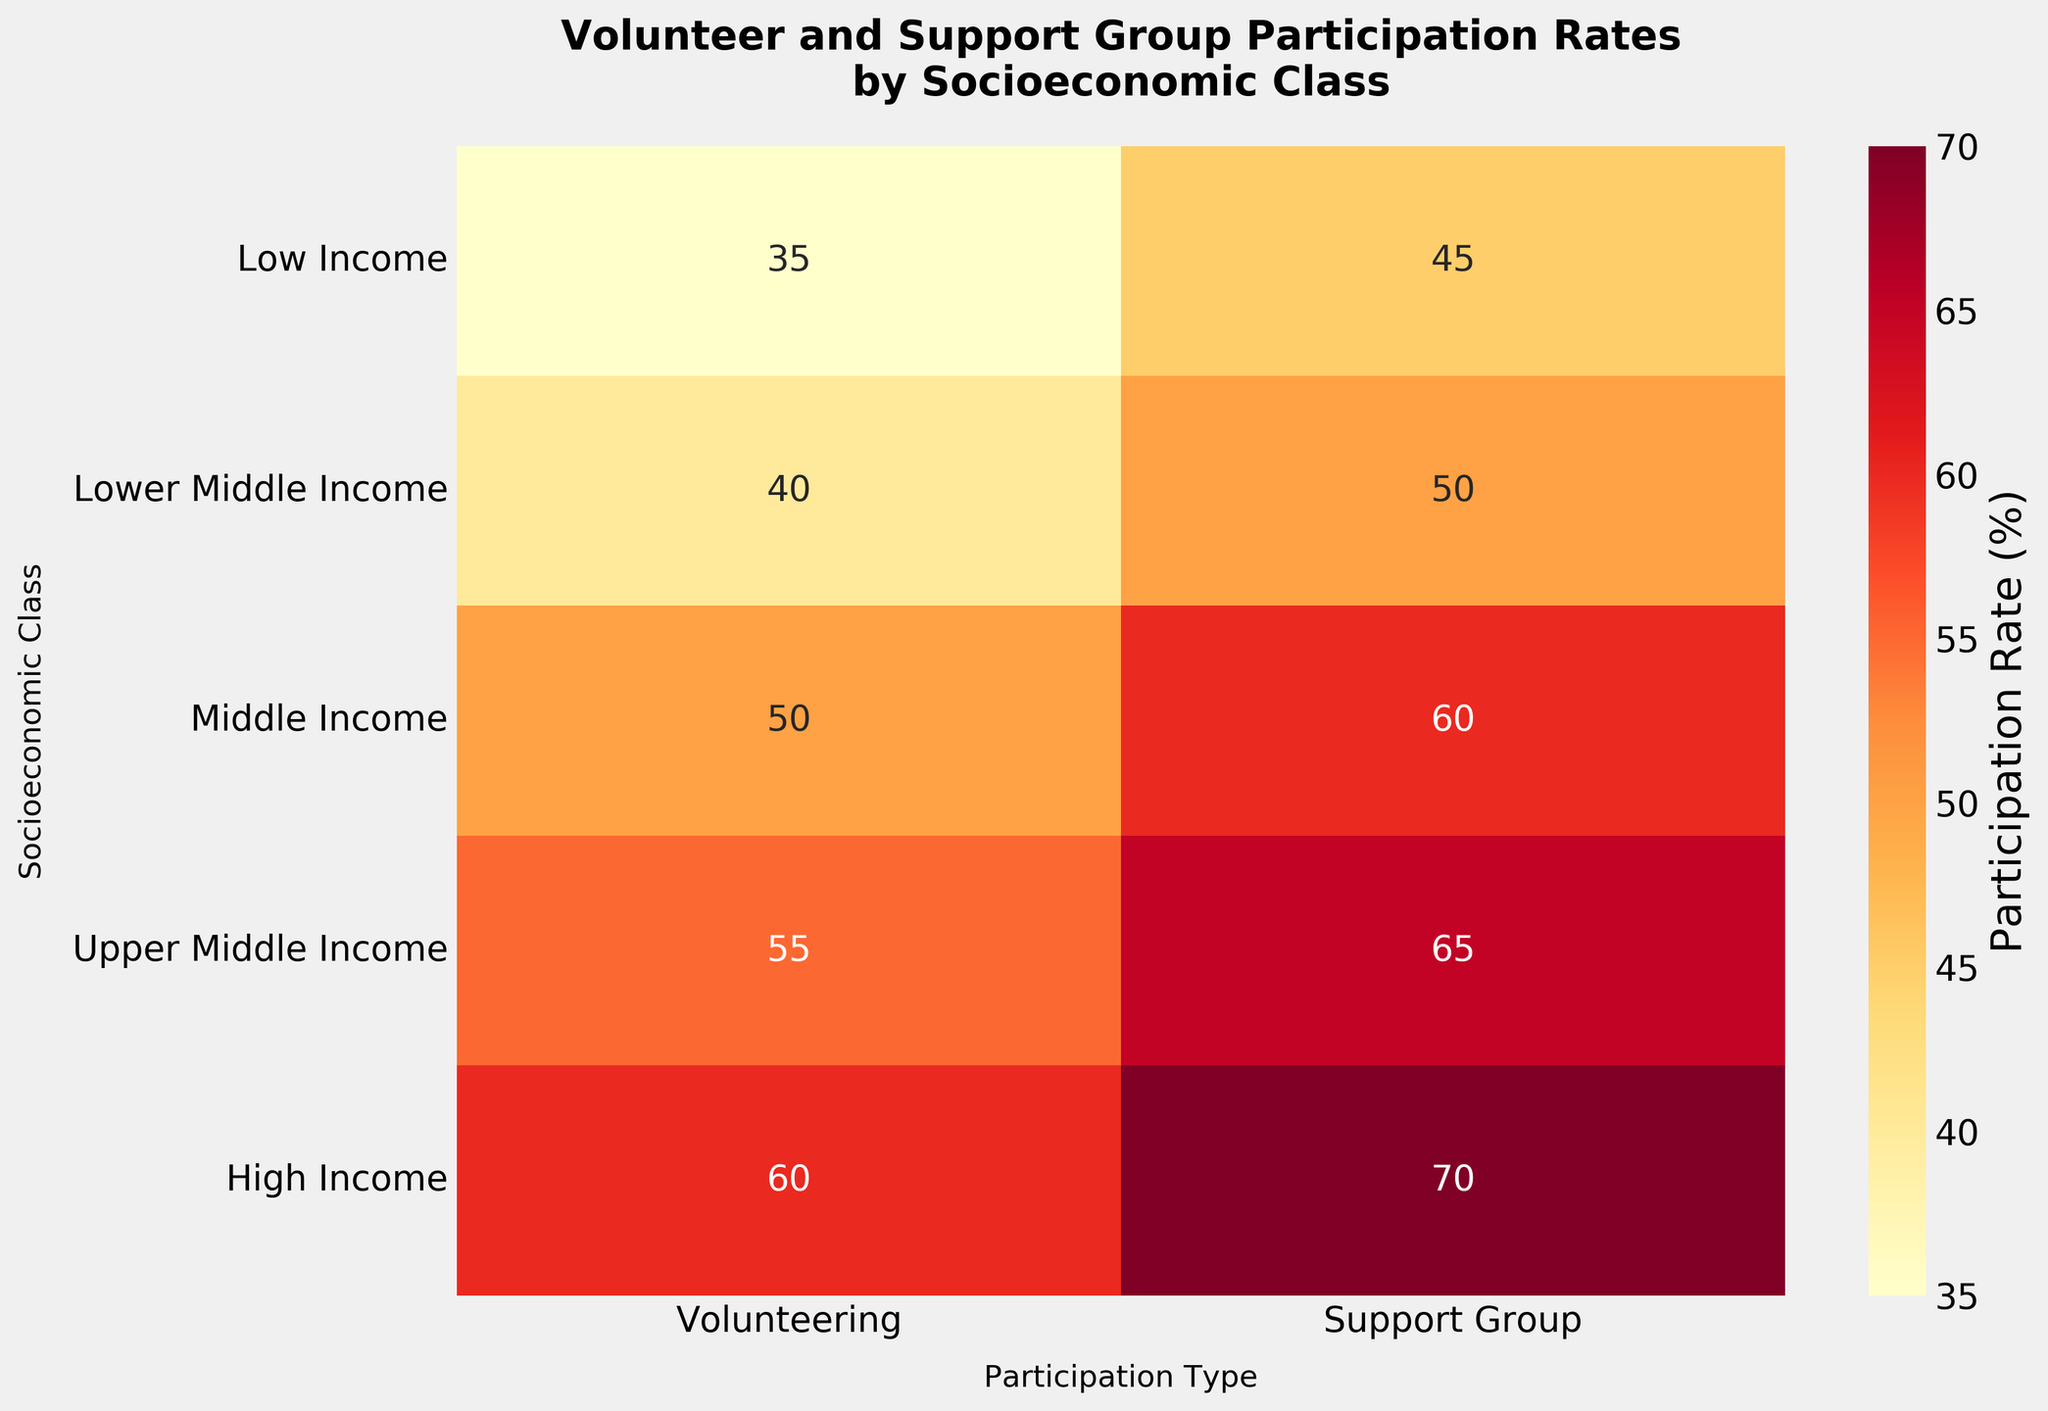What is the title of the heatmap? The title is usually displayed at the top of the heatmap. It reads "Volunteer and Support Group Participation Rates by Socioeconomic Class".
Answer: Volunteer and Support Group Participation Rates by Socioeconomic Class Which socioeconomic class has the highest volunteering rate? The heatmap shows the highest value in the "Volunteering" column, which corresponds to the "High Income" row.
Answer: High Income What is the volunteering rate for the Upper Middle Income class? The heatmap annotates values in each cell. The cell at the intersection of "Upper Middle Income" and "Volunteering" shows the number 55.
Answer: 55 How does the support group participation rate of the Low Income class compare to its volunteering rate? Compare the values in the "Low Income" row across the two columns. The "Support Group" column shows 45, which is higher than 35 in the "Volunteering" column.
Answer: Support group participation rate is higher What is the average support group participation rate across all socioeconomic classes? Sum the support group participation rates: 45, 50, 60, 65, and 70, which equals 290. Then divide by the total number of rows, which is 5: 290/5 = 58.
Answer: 58 Which socioeconomic class has the smallest difference between volunteering and support group participation rates? Calculate the differences for each class:
Low Income: 45 - 35 = 10
Lower Middle Income: 50 - 40 = 10
Middle Income: 60 - 50 = 10
Upper Middle Income: 65 - 55 = 10
High Income: 70 - 60 = 10
All differences are equal, so every class has an equal smallest difference of 10.
Answer: All classes have the smallest difference of 10 Is there a trend in participation rates as you move from Low Income to High Income? Observe the values in both columns; rates for volunteering and support group participation increase consistently from Low Income to High Income.
Answer: Yes, there is an increasing trend What is the total participation rate combining both volunteering and support group participation for the Middle Income class? Sum the Middle Income class rates for both columns: 50 (Volunteering) + 60 (Support Group) = 110.
Answer: 110 What is the general color trend observed in the heatmap as socioeconomic class increases? The color gradient shifts from lighter to darker shades which can be interpreted as lower to higher values in the scale, indicating increased participation rates.
Answer: Color darkens What is the overall range of participation rates displayed in the heatmap? The minimum rate is 35 (Volunteering for Low Income) and the maximum is 70 (Support Group for High Income), so the range is 70 - 35 = 35.
Answer: 35 